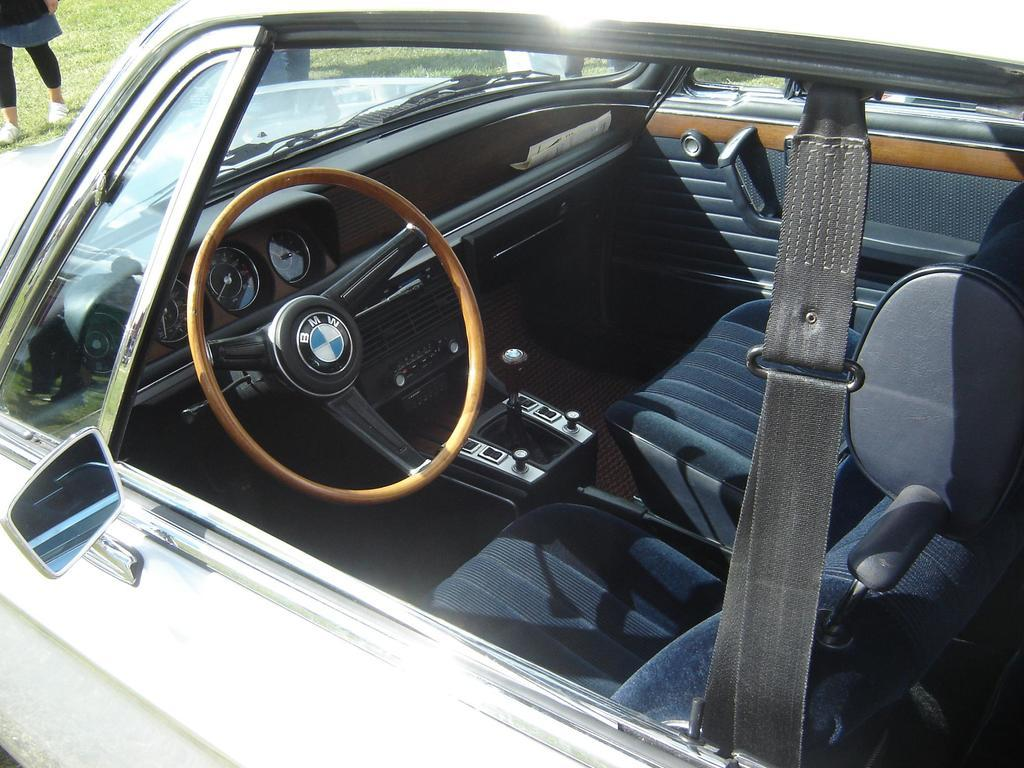What is the main subject of the image? The main subject of the image is a car. Can you describe the setting of the image? There is a person standing on the grass in the image. What type of badge is the person wearing on their stomach in the image? There is no person wearing a badge on their stomach in the image. What type of arithmetic problem is the car solving in the image? Cars do not solve arithmetic problems; they are vehicles used for transportation. 